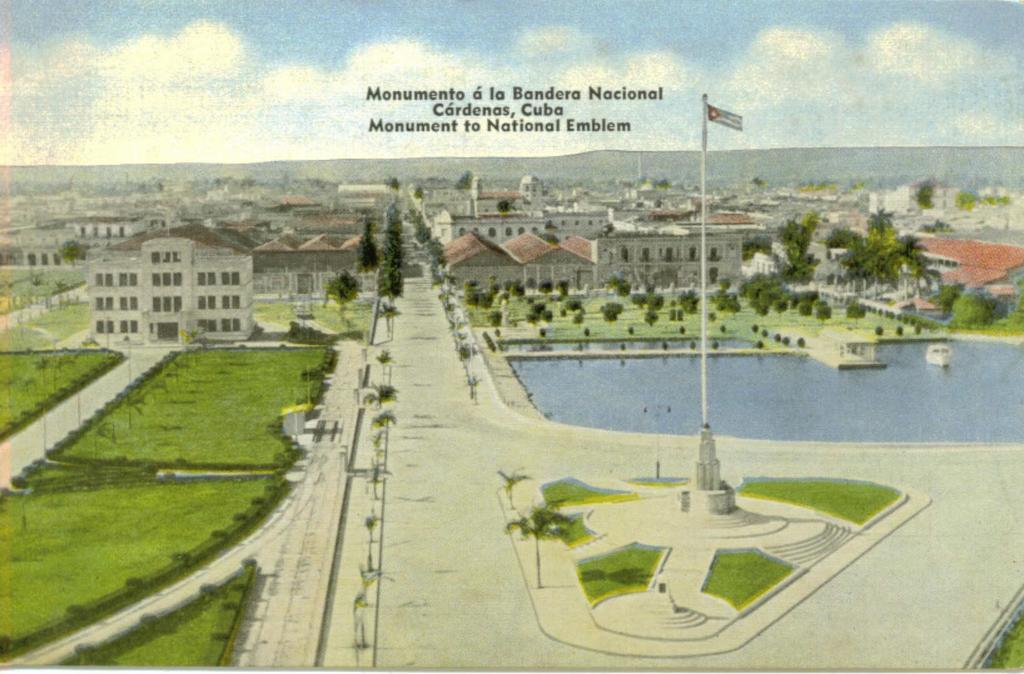What is featured on the poster in the image? The poster contains text and an image of buildings. What type of vegetation can be seen in the image? There are trees and grass in the image. What is the additional object present in the image? There is a flag in the image. What can be seen in the background of the image? There are mountains and the sky visible in the background of the image. What type of neck can be seen on the creator of the poster in the image? There is no creator or neck visible in the image; it only features a poster with text and an image of buildings, along with other elements like trees, grass, a flag, mountains, and the sky. 